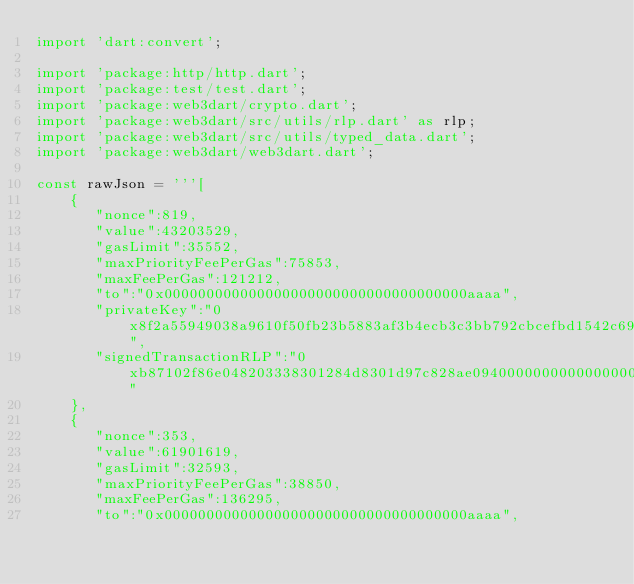<code> <loc_0><loc_0><loc_500><loc_500><_Dart_>import 'dart:convert';

import 'package:http/http.dart';
import 'package:test/test.dart';
import 'package:web3dart/crypto.dart';
import 'package:web3dart/src/utils/rlp.dart' as rlp;
import 'package:web3dart/src/utils/typed_data.dart';
import 'package:web3dart/web3dart.dart';

const rawJson = '''[
    {
       "nonce":819,
       "value":43203529,
       "gasLimit":35552,
       "maxPriorityFeePerGas":75853,
       "maxFeePerGas":121212,
       "to":"0x000000000000000000000000000000000000aaaa",
       "privateKey":"0x8f2a55949038a9610f50fb23b5883af3b4ecb3c3bb792cbcefbd1542c692be63",
       "signedTransactionRLP":"0xb87102f86e048203338301284d8301d97c828ae094000000000000000000000000000000000000aaaa8402933bc980c080a00f924cb68412c8f1cfd74d9b581c71eeaf94fff6abdde3e5b02ca6b2931dcf47a07dd1c50027c3e31f8b565e25ce68a5072110f61fce5eee81b195dd51273c2f83"
    },
    {
       "nonce":353,
       "value":61901619,
       "gasLimit":32593,
       "maxPriorityFeePerGas":38850,
       "maxFeePerGas":136295,
       "to":"0x000000000000000000000000000000000000aaaa",</code> 